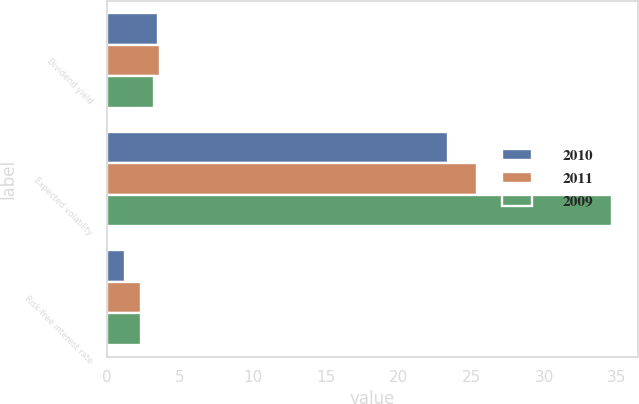Convert chart to OTSL. <chart><loc_0><loc_0><loc_500><loc_500><stacked_bar_chart><ecel><fcel>Dividend yield<fcel>Expected volatility<fcel>Risk-free interest rate<nl><fcel>2010<fcel>3.5<fcel>23.4<fcel>1.2<nl><fcel>2011<fcel>3.6<fcel>25.4<fcel>2.3<nl><fcel>2009<fcel>3.2<fcel>34.7<fcel>2.3<nl></chart> 